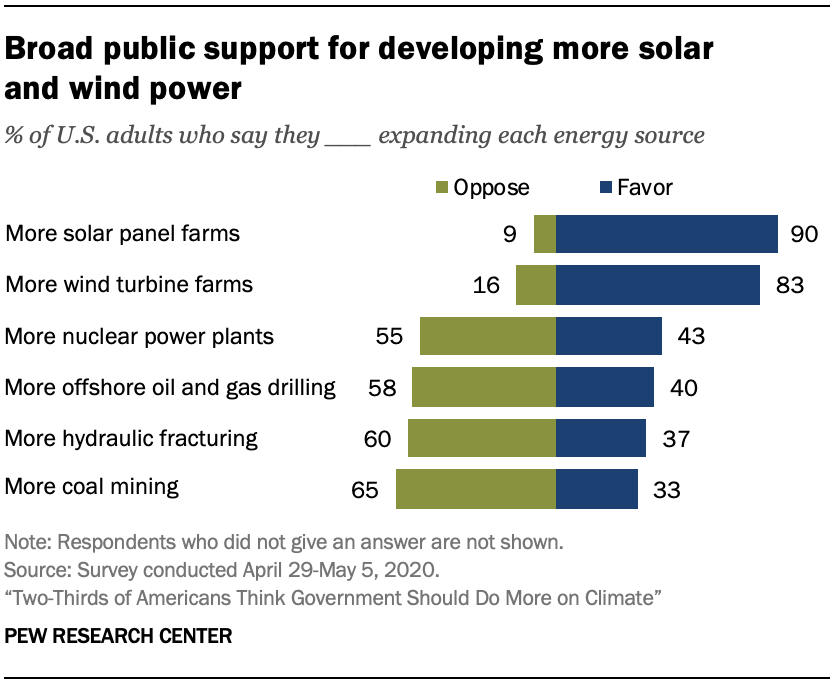Outline some significant characteristics in this image. The sum of the smallest and largest difference between green and blue bars is 93. The smallest value of green bar is 9. 